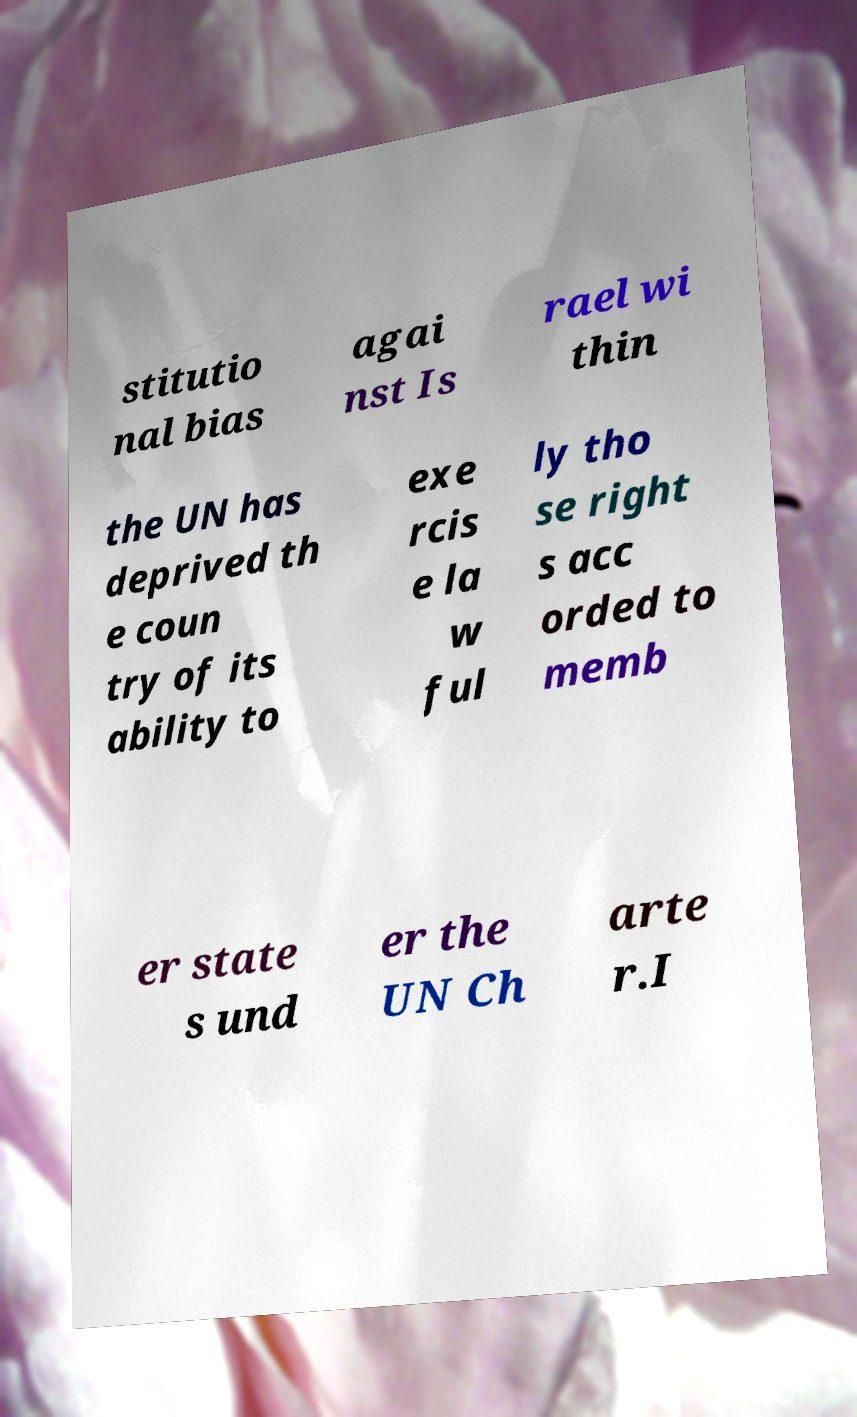What messages or text are displayed in this image? I need them in a readable, typed format. stitutio nal bias agai nst Is rael wi thin the UN has deprived th e coun try of its ability to exe rcis e la w ful ly tho se right s acc orded to memb er state s und er the UN Ch arte r.I 